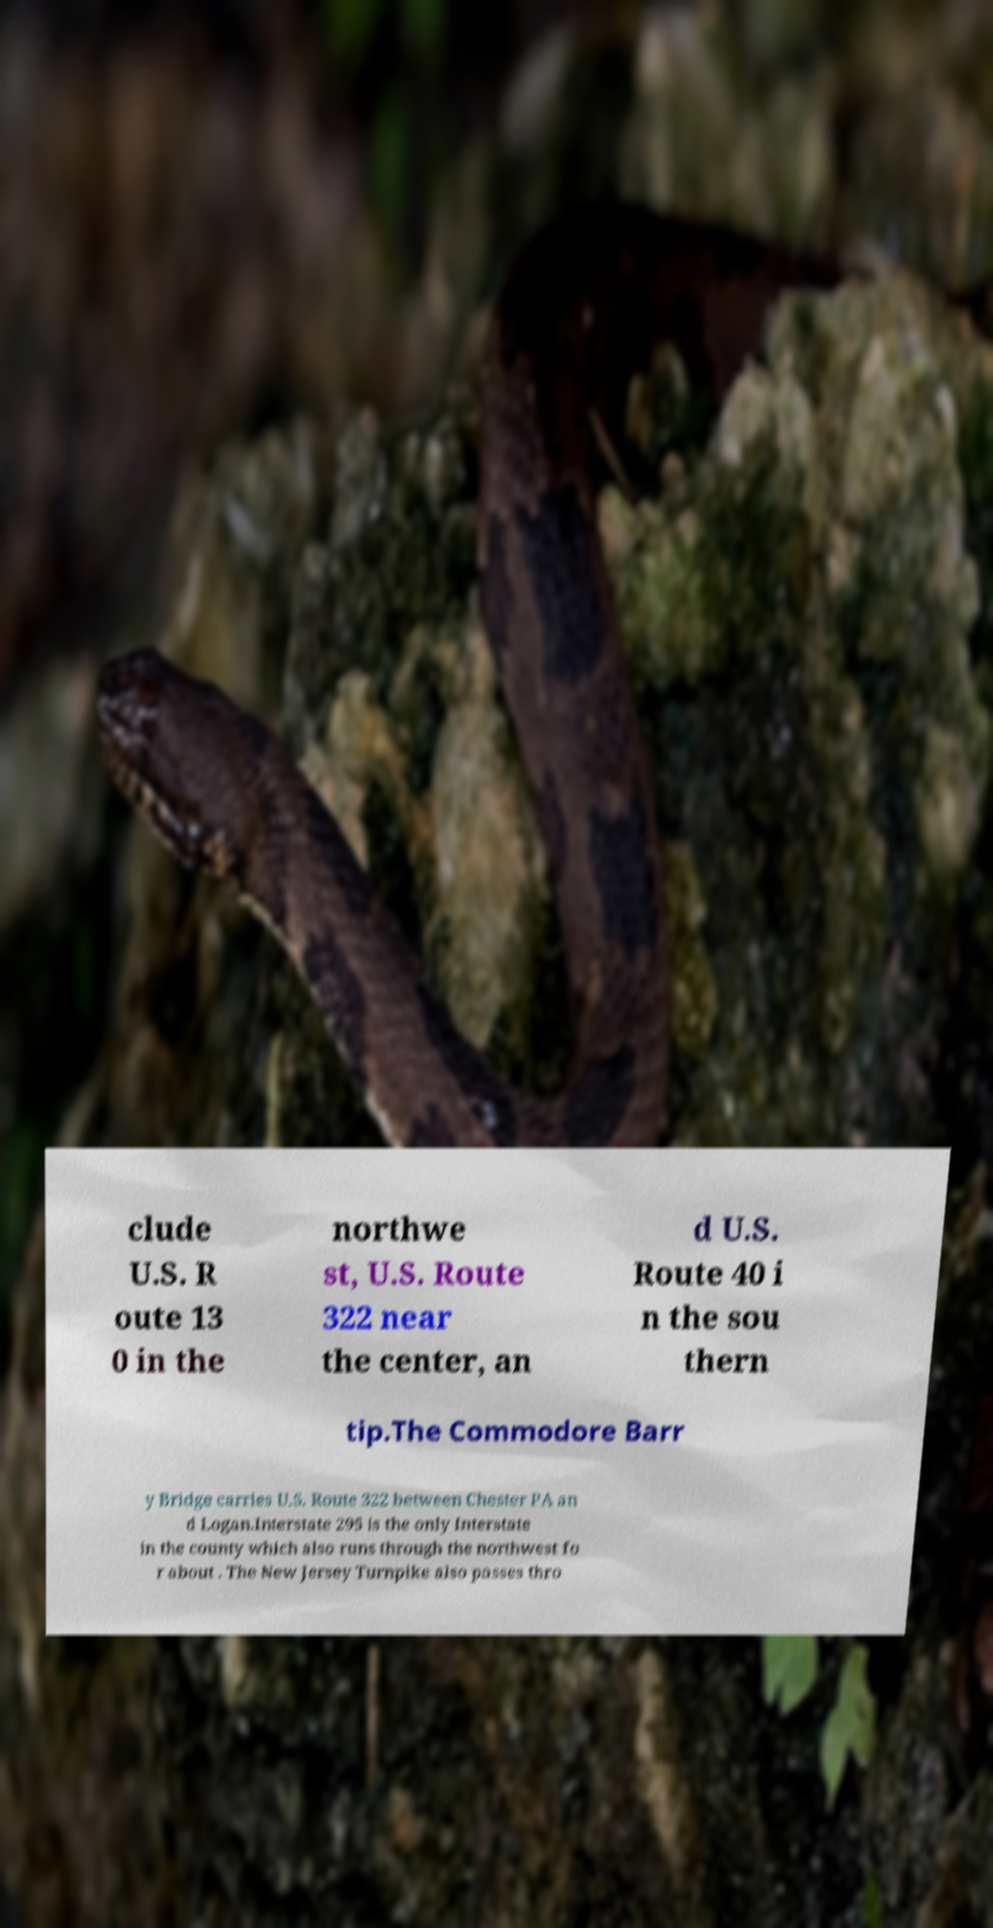For documentation purposes, I need the text within this image transcribed. Could you provide that? clude U.S. R oute 13 0 in the northwe st, U.S. Route 322 near the center, an d U.S. Route 40 i n the sou thern tip.The Commodore Barr y Bridge carries U.S. Route 322 between Chester PA an d Logan.Interstate 295 is the only Interstate in the county which also runs through the northwest fo r about . The New Jersey Turnpike also passes thro 